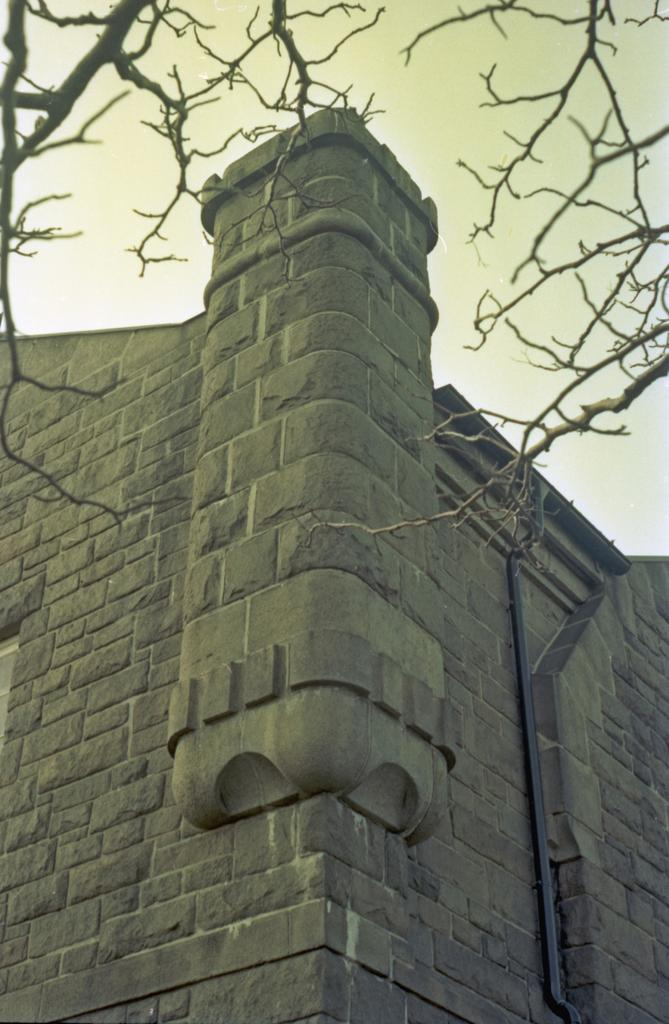What is attached to the wall in the image? There is a pipe on the wall in the image. What type of natural element is present in the image? There are branches of a tree in the image. What is visible in the background of the image? The sky is visible in the image. How many kittens are playing with the branches in the image? There are no kittens present in the image; it features a pipe on the wall and branches of a tree. What wish can be granted by looking at the sky in the image? There is no mention of wishes or granting them in the image; it simply shows a pipe on the wall, branches of a tree, and the sky. 